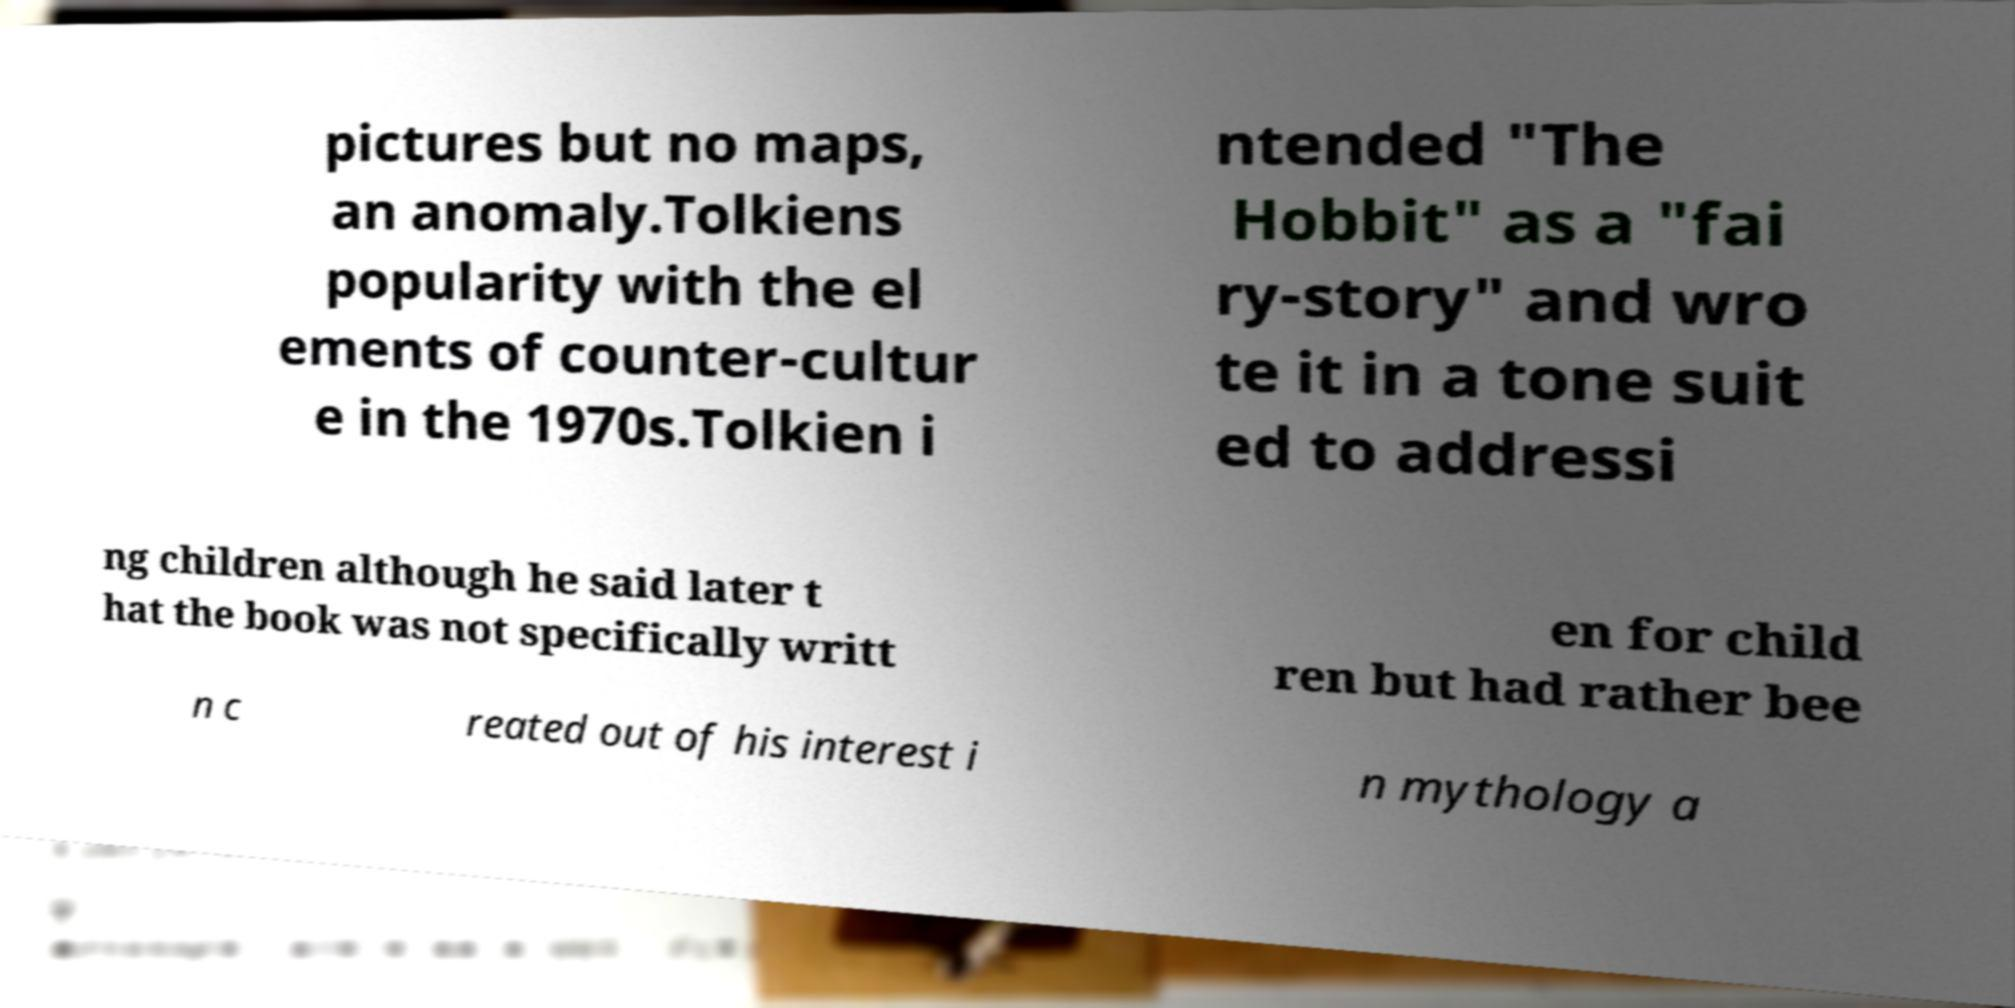There's text embedded in this image that I need extracted. Can you transcribe it verbatim? pictures but no maps, an anomaly.Tolkiens popularity with the el ements of counter-cultur e in the 1970s.Tolkien i ntended "The Hobbit" as a "fai ry-story" and wro te it in a tone suit ed to addressi ng children although he said later t hat the book was not specifically writt en for child ren but had rather bee n c reated out of his interest i n mythology a 